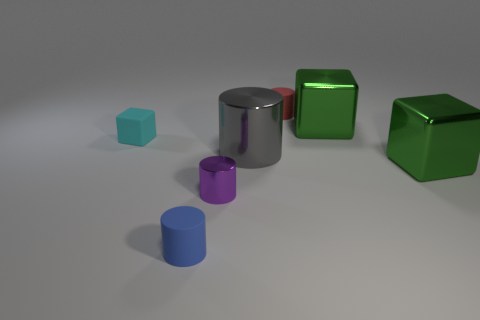What size is the cylinder that is both in front of the gray metallic thing and right of the tiny blue matte object?
Keep it short and to the point. Small. How big is the metal object right of the big metal block behind the small matte block left of the small red matte object?
Ensure brevity in your answer.  Large. How big is the red cylinder?
Ensure brevity in your answer.  Small. There is a matte cylinder that is in front of the tiny cylinder that is on the right side of the purple shiny object; are there any cyan matte cubes left of it?
Give a very brief answer. Yes. What number of large things are either metallic cubes or purple matte cubes?
Keep it short and to the point. 2. Is there any other thing that has the same color as the big metal cylinder?
Keep it short and to the point. No. Is the size of the matte cylinder in front of the cyan rubber object the same as the gray cylinder?
Make the answer very short. No. What is the color of the block in front of the small rubber object that is left of the small rubber cylinder that is in front of the small red cylinder?
Offer a very short reply. Green. The matte cube has what color?
Offer a very short reply. Cyan. Is the green block in front of the gray metal cylinder made of the same material as the cylinder that is behind the tiny cube?
Offer a terse response. No. 